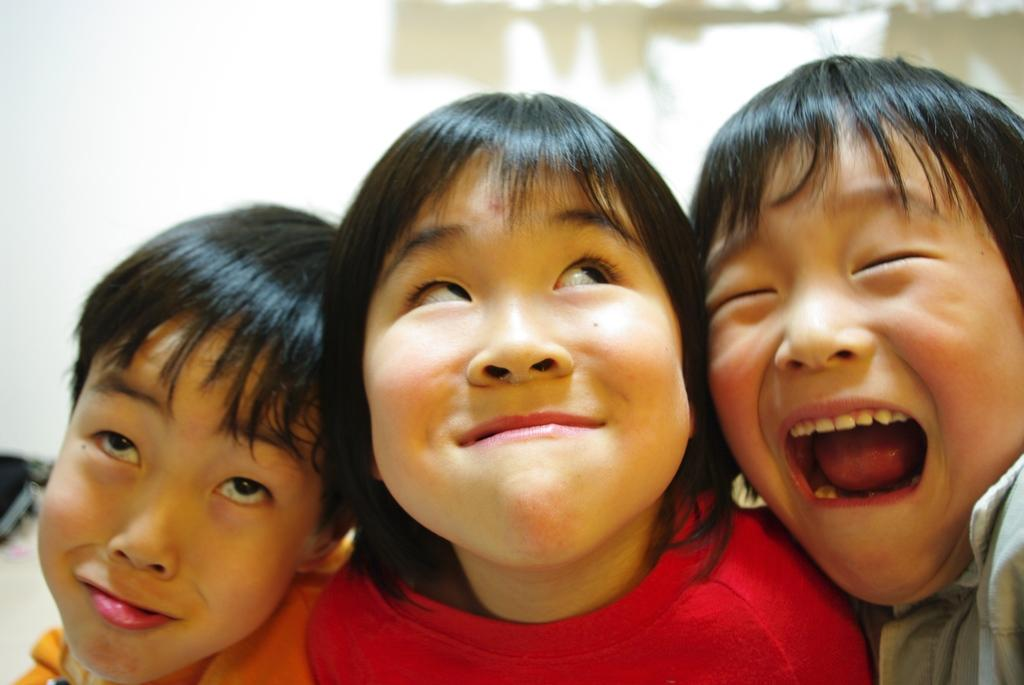Who is present in the image? There is a girl and boys in the image. Can you describe the background of the image? The background of the image is blurry. What type of shoes are the friends wearing in the image? There is no mention of friends in the image, and no shoes are visible. 